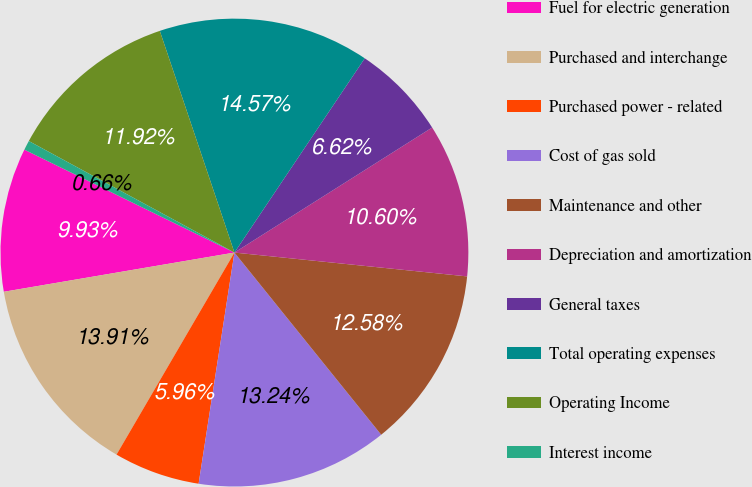Convert chart. <chart><loc_0><loc_0><loc_500><loc_500><pie_chart><fcel>Fuel for electric generation<fcel>Purchased and interchange<fcel>Purchased power - related<fcel>Cost of gas sold<fcel>Maintenance and other<fcel>Depreciation and amortization<fcel>General taxes<fcel>Total operating expenses<fcel>Operating Income<fcel>Interest income<nl><fcel>9.93%<fcel>13.91%<fcel>5.96%<fcel>13.24%<fcel>12.58%<fcel>10.6%<fcel>6.62%<fcel>14.57%<fcel>11.92%<fcel>0.66%<nl></chart> 